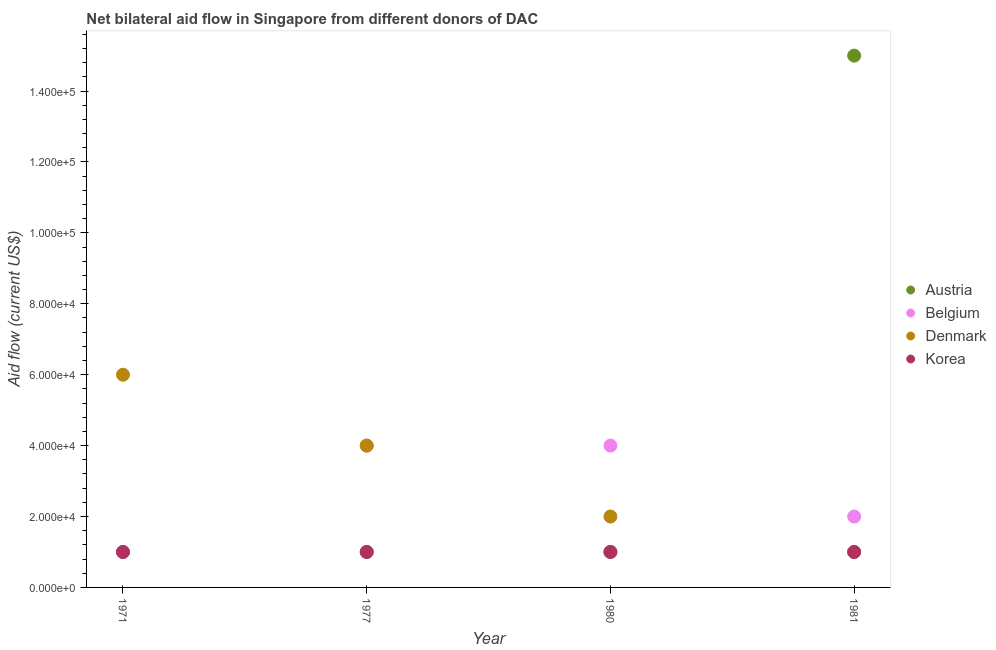Is the number of dotlines equal to the number of legend labels?
Make the answer very short. Yes. What is the amount of aid given by korea in 1977?
Keep it short and to the point. 10000. Across all years, what is the maximum amount of aid given by belgium?
Your response must be concise. 4.00e+04. Across all years, what is the minimum amount of aid given by austria?
Ensure brevity in your answer.  10000. In which year was the amount of aid given by denmark maximum?
Provide a succinct answer. 1971. In which year was the amount of aid given by denmark minimum?
Provide a short and direct response. 1981. What is the total amount of aid given by korea in the graph?
Give a very brief answer. 4.00e+04. What is the difference between the amount of aid given by belgium in 1971 and that in 1980?
Make the answer very short. -3.00e+04. What is the difference between the amount of aid given by austria in 1981 and the amount of aid given by denmark in 1971?
Provide a succinct answer. 9.00e+04. What is the average amount of aid given by korea per year?
Offer a very short reply. 10000. In the year 1977, what is the difference between the amount of aid given by belgium and amount of aid given by austria?
Your response must be concise. 3.00e+04. In how many years, is the amount of aid given by austria greater than 16000 US$?
Ensure brevity in your answer.  1. What is the ratio of the amount of aid given by korea in 1977 to that in 1981?
Make the answer very short. 1. Is the difference between the amount of aid given by belgium in 1971 and 1977 greater than the difference between the amount of aid given by denmark in 1971 and 1977?
Offer a very short reply. No. What is the difference between the highest and the second highest amount of aid given by denmark?
Provide a short and direct response. 2.00e+04. What is the difference between the highest and the lowest amount of aid given by korea?
Keep it short and to the point. 0. Is the sum of the amount of aid given by denmark in 1971 and 1980 greater than the maximum amount of aid given by belgium across all years?
Your answer should be very brief. Yes. Is the amount of aid given by belgium strictly greater than the amount of aid given by denmark over the years?
Ensure brevity in your answer.  No. Is the amount of aid given by denmark strictly less than the amount of aid given by belgium over the years?
Keep it short and to the point. No. How many years are there in the graph?
Offer a very short reply. 4. What is the difference between two consecutive major ticks on the Y-axis?
Make the answer very short. 2.00e+04. Are the values on the major ticks of Y-axis written in scientific E-notation?
Offer a very short reply. Yes. Does the graph contain grids?
Your answer should be very brief. No. How many legend labels are there?
Provide a short and direct response. 4. What is the title of the graph?
Give a very brief answer. Net bilateral aid flow in Singapore from different donors of DAC. Does "Budget management" appear as one of the legend labels in the graph?
Give a very brief answer. No. What is the label or title of the X-axis?
Your response must be concise. Year. What is the label or title of the Y-axis?
Provide a short and direct response. Aid flow (current US$). What is the Aid flow (current US$) of Austria in 1971?
Your answer should be compact. 10000. What is the Aid flow (current US$) of Belgium in 1971?
Your answer should be compact. 10000. What is the Aid flow (current US$) of Denmark in 1971?
Your response must be concise. 6.00e+04. What is the Aid flow (current US$) of Austria in 1977?
Your response must be concise. 10000. What is the Aid flow (current US$) in Denmark in 1977?
Your response must be concise. 4.00e+04. What is the Aid flow (current US$) in Austria in 1980?
Offer a terse response. 10000. What is the Aid flow (current US$) of Belgium in 1981?
Your answer should be compact. 2.00e+04. What is the Aid flow (current US$) in Denmark in 1981?
Your response must be concise. 10000. Across all years, what is the maximum Aid flow (current US$) in Austria?
Offer a terse response. 1.50e+05. Across all years, what is the minimum Aid flow (current US$) of Belgium?
Your answer should be compact. 10000. What is the total Aid flow (current US$) in Austria in the graph?
Ensure brevity in your answer.  1.80e+05. What is the total Aid flow (current US$) of Korea in the graph?
Give a very brief answer. 4.00e+04. What is the difference between the Aid flow (current US$) of Austria in 1971 and that in 1977?
Provide a short and direct response. 0. What is the difference between the Aid flow (current US$) of Austria in 1971 and that in 1980?
Your answer should be very brief. 0. What is the difference between the Aid flow (current US$) in Belgium in 1971 and that in 1980?
Make the answer very short. -3.00e+04. What is the difference between the Aid flow (current US$) in Austria in 1971 and that in 1981?
Provide a short and direct response. -1.40e+05. What is the difference between the Aid flow (current US$) in Denmark in 1971 and that in 1981?
Provide a succinct answer. 5.00e+04. What is the difference between the Aid flow (current US$) of Austria in 1977 and that in 1980?
Offer a very short reply. 0. What is the difference between the Aid flow (current US$) in Belgium in 1977 and that in 1980?
Offer a terse response. 0. What is the difference between the Aid flow (current US$) in Belgium in 1977 and that in 1981?
Offer a terse response. 2.00e+04. What is the difference between the Aid flow (current US$) in Denmark in 1977 and that in 1981?
Ensure brevity in your answer.  3.00e+04. What is the difference between the Aid flow (current US$) in Korea in 1977 and that in 1981?
Make the answer very short. 0. What is the difference between the Aid flow (current US$) of Austria in 1980 and that in 1981?
Your response must be concise. -1.40e+05. What is the difference between the Aid flow (current US$) in Korea in 1980 and that in 1981?
Keep it short and to the point. 0. What is the difference between the Aid flow (current US$) in Austria in 1971 and the Aid flow (current US$) in Denmark in 1977?
Your answer should be compact. -3.00e+04. What is the difference between the Aid flow (current US$) in Austria in 1971 and the Aid flow (current US$) in Korea in 1977?
Your answer should be very brief. 0. What is the difference between the Aid flow (current US$) in Belgium in 1971 and the Aid flow (current US$) in Denmark in 1977?
Provide a succinct answer. -3.00e+04. What is the difference between the Aid flow (current US$) in Denmark in 1971 and the Aid flow (current US$) in Korea in 1977?
Provide a succinct answer. 5.00e+04. What is the difference between the Aid flow (current US$) of Austria in 1971 and the Aid flow (current US$) of Belgium in 1980?
Keep it short and to the point. -3.00e+04. What is the difference between the Aid flow (current US$) of Austria in 1971 and the Aid flow (current US$) of Denmark in 1980?
Your answer should be very brief. -10000. What is the difference between the Aid flow (current US$) in Austria in 1971 and the Aid flow (current US$) in Korea in 1980?
Offer a very short reply. 0. What is the difference between the Aid flow (current US$) of Belgium in 1971 and the Aid flow (current US$) of Korea in 1980?
Provide a succinct answer. 0. What is the difference between the Aid flow (current US$) in Belgium in 1971 and the Aid flow (current US$) in Denmark in 1981?
Your response must be concise. 0. What is the difference between the Aid flow (current US$) in Denmark in 1971 and the Aid flow (current US$) in Korea in 1981?
Keep it short and to the point. 5.00e+04. What is the difference between the Aid flow (current US$) of Belgium in 1977 and the Aid flow (current US$) of Denmark in 1980?
Provide a succinct answer. 2.00e+04. What is the difference between the Aid flow (current US$) of Denmark in 1977 and the Aid flow (current US$) of Korea in 1980?
Ensure brevity in your answer.  3.00e+04. What is the difference between the Aid flow (current US$) in Austria in 1977 and the Aid flow (current US$) in Denmark in 1981?
Make the answer very short. 0. What is the difference between the Aid flow (current US$) of Austria in 1977 and the Aid flow (current US$) of Korea in 1981?
Offer a terse response. 0. What is the difference between the Aid flow (current US$) of Belgium in 1977 and the Aid flow (current US$) of Denmark in 1981?
Provide a succinct answer. 3.00e+04. What is the difference between the Aid flow (current US$) in Belgium in 1977 and the Aid flow (current US$) in Korea in 1981?
Provide a short and direct response. 3.00e+04. What is the difference between the Aid flow (current US$) of Austria in 1980 and the Aid flow (current US$) of Denmark in 1981?
Offer a very short reply. 0. What is the difference between the Aid flow (current US$) in Austria in 1980 and the Aid flow (current US$) in Korea in 1981?
Keep it short and to the point. 0. What is the difference between the Aid flow (current US$) in Belgium in 1980 and the Aid flow (current US$) in Korea in 1981?
Offer a terse response. 3.00e+04. What is the average Aid flow (current US$) in Austria per year?
Your answer should be compact. 4.50e+04. What is the average Aid flow (current US$) in Belgium per year?
Ensure brevity in your answer.  2.75e+04. What is the average Aid flow (current US$) of Denmark per year?
Your answer should be compact. 3.25e+04. What is the average Aid flow (current US$) of Korea per year?
Provide a short and direct response. 10000. In the year 1971, what is the difference between the Aid flow (current US$) of Belgium and Aid flow (current US$) of Denmark?
Give a very brief answer. -5.00e+04. In the year 1977, what is the difference between the Aid flow (current US$) in Austria and Aid flow (current US$) in Belgium?
Offer a terse response. -3.00e+04. In the year 1980, what is the difference between the Aid flow (current US$) in Austria and Aid flow (current US$) in Denmark?
Make the answer very short. -10000. In the year 1980, what is the difference between the Aid flow (current US$) of Austria and Aid flow (current US$) of Korea?
Give a very brief answer. 0. In the year 1980, what is the difference between the Aid flow (current US$) of Denmark and Aid flow (current US$) of Korea?
Make the answer very short. 10000. In the year 1981, what is the difference between the Aid flow (current US$) in Austria and Aid flow (current US$) in Denmark?
Offer a terse response. 1.40e+05. In the year 1981, what is the difference between the Aid flow (current US$) of Belgium and Aid flow (current US$) of Denmark?
Your answer should be compact. 10000. In the year 1981, what is the difference between the Aid flow (current US$) of Denmark and Aid flow (current US$) of Korea?
Offer a very short reply. 0. What is the ratio of the Aid flow (current US$) of Belgium in 1971 to that in 1977?
Ensure brevity in your answer.  0.25. What is the ratio of the Aid flow (current US$) in Korea in 1971 to that in 1977?
Ensure brevity in your answer.  1. What is the ratio of the Aid flow (current US$) of Belgium in 1971 to that in 1980?
Offer a very short reply. 0.25. What is the ratio of the Aid flow (current US$) of Denmark in 1971 to that in 1980?
Offer a terse response. 3. What is the ratio of the Aid flow (current US$) in Austria in 1971 to that in 1981?
Make the answer very short. 0.07. What is the ratio of the Aid flow (current US$) in Belgium in 1971 to that in 1981?
Keep it short and to the point. 0.5. What is the ratio of the Aid flow (current US$) in Denmark in 1971 to that in 1981?
Make the answer very short. 6. What is the ratio of the Aid flow (current US$) of Korea in 1971 to that in 1981?
Ensure brevity in your answer.  1. What is the ratio of the Aid flow (current US$) of Austria in 1977 to that in 1980?
Provide a short and direct response. 1. What is the ratio of the Aid flow (current US$) in Belgium in 1977 to that in 1980?
Make the answer very short. 1. What is the ratio of the Aid flow (current US$) of Denmark in 1977 to that in 1980?
Provide a short and direct response. 2. What is the ratio of the Aid flow (current US$) in Austria in 1977 to that in 1981?
Your answer should be compact. 0.07. What is the ratio of the Aid flow (current US$) in Belgium in 1977 to that in 1981?
Make the answer very short. 2. What is the ratio of the Aid flow (current US$) of Korea in 1977 to that in 1981?
Ensure brevity in your answer.  1. What is the ratio of the Aid flow (current US$) in Austria in 1980 to that in 1981?
Provide a succinct answer. 0.07. What is the ratio of the Aid flow (current US$) in Denmark in 1980 to that in 1981?
Ensure brevity in your answer.  2. What is the ratio of the Aid flow (current US$) of Korea in 1980 to that in 1981?
Your answer should be compact. 1. What is the difference between the highest and the second highest Aid flow (current US$) in Austria?
Provide a short and direct response. 1.40e+05. What is the difference between the highest and the second highest Aid flow (current US$) in Korea?
Offer a terse response. 0. What is the difference between the highest and the lowest Aid flow (current US$) of Austria?
Your answer should be compact. 1.40e+05. What is the difference between the highest and the lowest Aid flow (current US$) in Korea?
Your response must be concise. 0. 